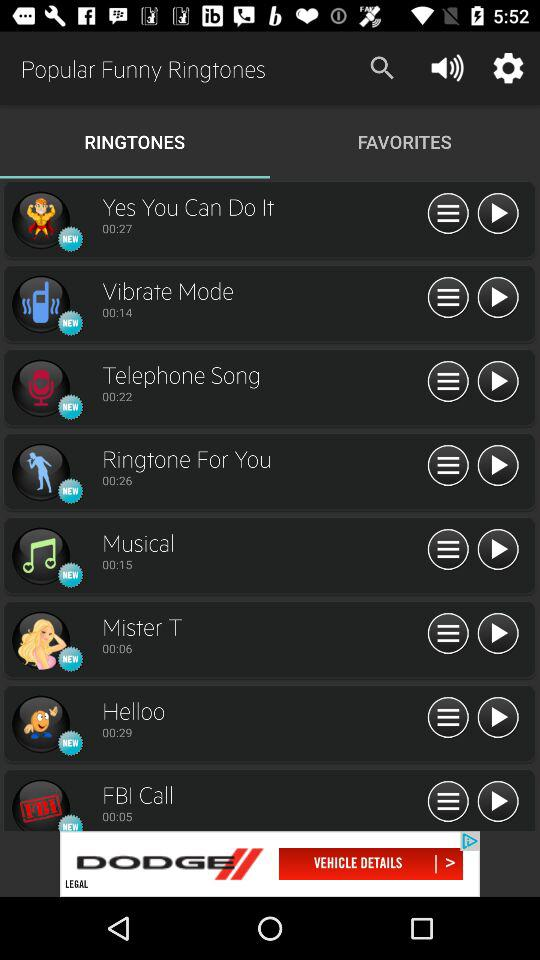What tab has been selected? The tab that has been selected is "RINGTONES". 